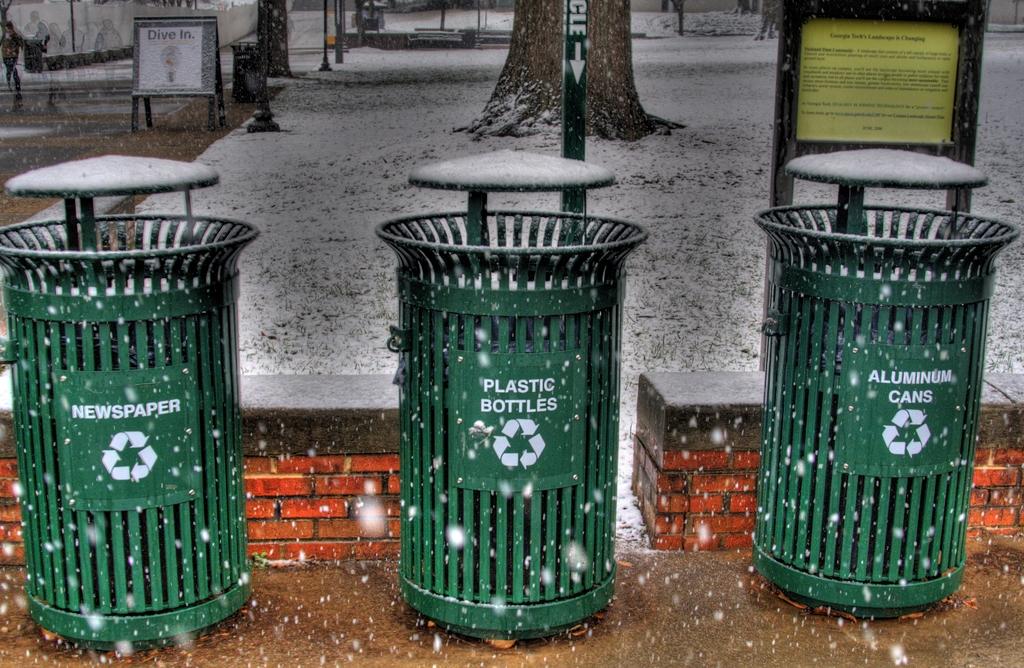What is the first trashcan ment for?
Give a very brief answer. Newspaper. What material should be placed in the center recycling bin?
Your answer should be compact. Plastic bottles. 